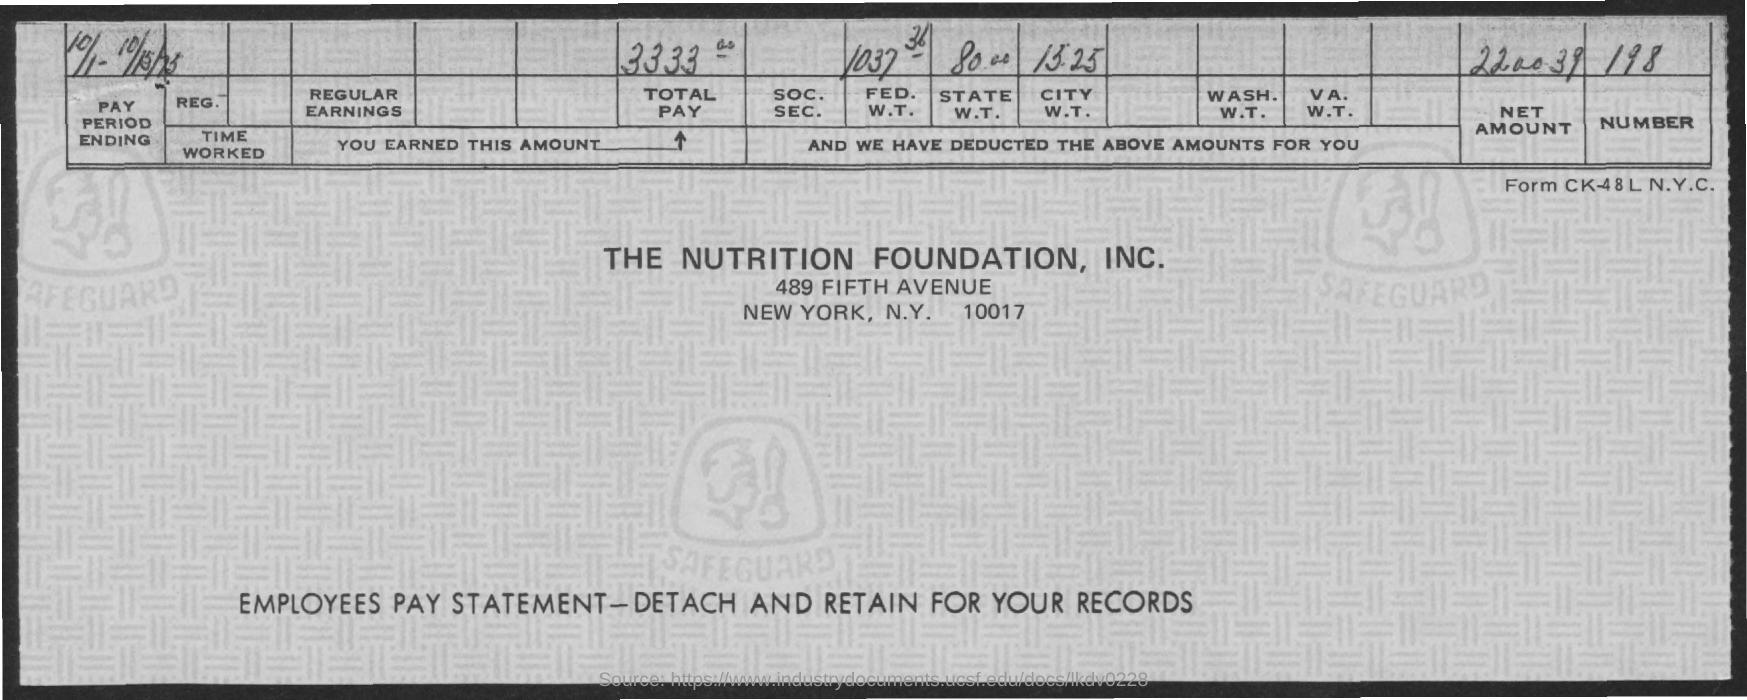What is this statement about?
Provide a short and direct response. Employees pay statement. What is the total pay?
Give a very brief answer. 3333. What is the net amount?
Offer a terse response. 220039. 